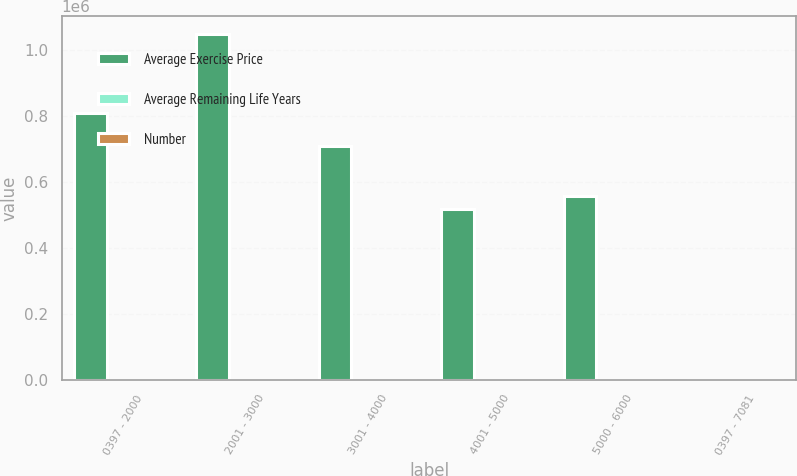Convert chart. <chart><loc_0><loc_0><loc_500><loc_500><stacked_bar_chart><ecel><fcel>0397 - 2000<fcel>2001 - 3000<fcel>3001 - 4000<fcel>4001 - 5000<fcel>5000 - 6000<fcel>0397 - 7081<nl><fcel>Average Exercise Price<fcel>808000<fcel>1.05e+06<fcel>708000<fcel>518000<fcel>558000<fcel>30.84<nl><fcel>Average Remaining Life Years<fcel>17.31<fcel>21.93<fcel>31.47<fcel>43.59<fcel>53.69<fcel>30.84<nl><fcel>Number<fcel>4.1<fcel>4.8<fcel>4.8<fcel>5.3<fcel>6.3<fcel>5<nl></chart> 